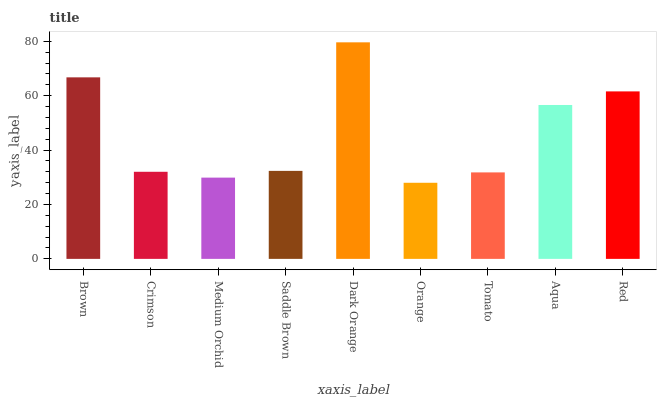Is Crimson the minimum?
Answer yes or no. No. Is Crimson the maximum?
Answer yes or no. No. Is Brown greater than Crimson?
Answer yes or no. Yes. Is Crimson less than Brown?
Answer yes or no. Yes. Is Crimson greater than Brown?
Answer yes or no. No. Is Brown less than Crimson?
Answer yes or no. No. Is Saddle Brown the high median?
Answer yes or no. Yes. Is Saddle Brown the low median?
Answer yes or no. Yes. Is Red the high median?
Answer yes or no. No. Is Medium Orchid the low median?
Answer yes or no. No. 